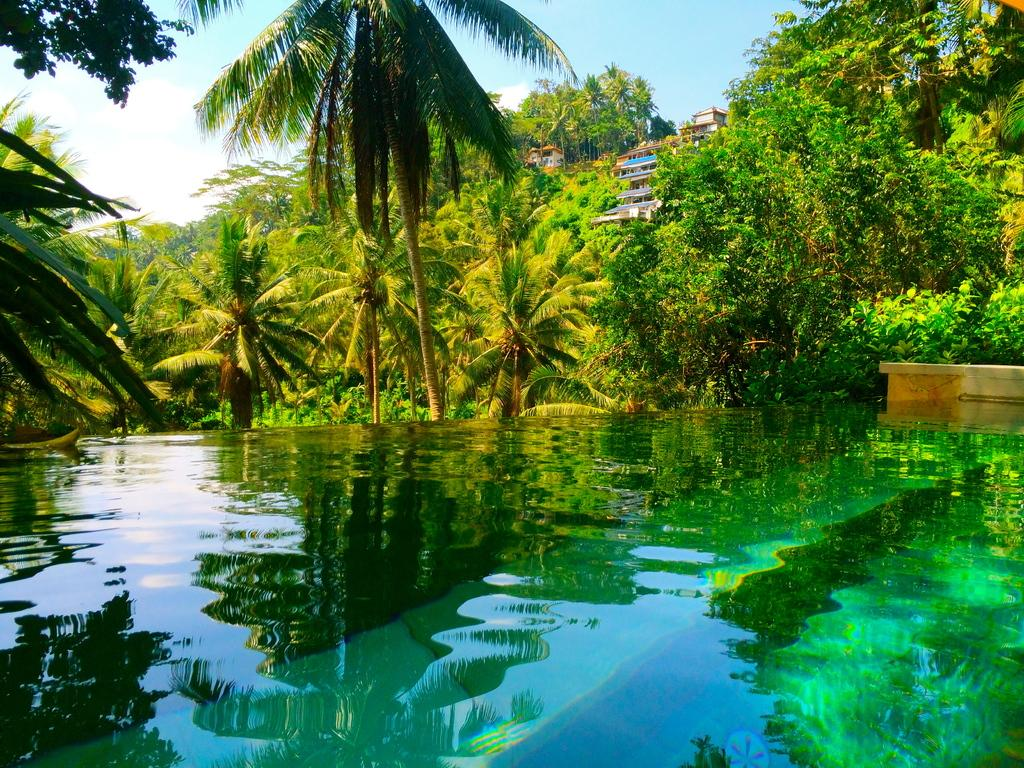What is the primary element visible in the image? There is water in the image. What type of furniture can be seen on the right side of the image? There is a wooden table on the right side of the image. What can be seen in the distance in the image? There are trees, buildings, and the sky visible in the background of the image. Who is the friend that can be seen in the image? There is no friend present in the image. What type of plants can be seen growing in the water? There are no plants visible in the water in the image. 